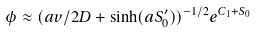<formula> <loc_0><loc_0><loc_500><loc_500>\phi \approx ( a v / 2 D + \sinh ( a S _ { 0 } ^ { \prime } ) ) ^ { - 1 / 2 } e ^ { C _ { 1 } + S _ { 0 } }</formula> 